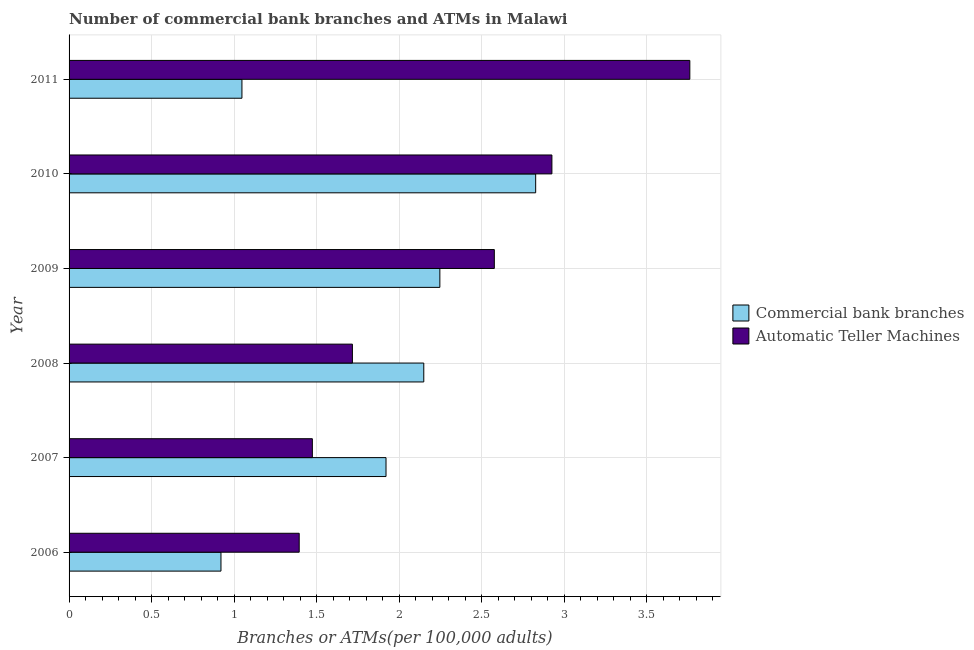Are the number of bars on each tick of the Y-axis equal?
Offer a very short reply. Yes. How many bars are there on the 3rd tick from the bottom?
Make the answer very short. 2. What is the label of the 1st group of bars from the top?
Provide a succinct answer. 2011. In how many cases, is the number of bars for a given year not equal to the number of legend labels?
Offer a terse response. 0. What is the number of atms in 2010?
Make the answer very short. 2.93. Across all years, what is the maximum number of atms?
Give a very brief answer. 3.76. Across all years, what is the minimum number of commercal bank branches?
Provide a short and direct response. 0.92. In which year was the number of atms minimum?
Your answer should be very brief. 2006. What is the total number of commercal bank branches in the graph?
Offer a terse response. 11.11. What is the difference between the number of atms in 2006 and that in 2007?
Your answer should be very brief. -0.08. What is the difference between the number of atms in 2006 and the number of commercal bank branches in 2008?
Your answer should be very brief. -0.75. What is the average number of atms per year?
Provide a short and direct response. 2.31. In the year 2007, what is the difference between the number of commercal bank branches and number of atms?
Keep it short and to the point. 0.45. In how many years, is the number of atms greater than 0.30000000000000004 ?
Provide a succinct answer. 6. What is the ratio of the number of commercal bank branches in 2009 to that in 2011?
Make the answer very short. 2.15. What is the difference between the highest and the second highest number of commercal bank branches?
Your answer should be very brief. 0.58. What is the difference between the highest and the lowest number of commercal bank branches?
Keep it short and to the point. 1.91. In how many years, is the number of commercal bank branches greater than the average number of commercal bank branches taken over all years?
Your answer should be very brief. 4. Is the sum of the number of atms in 2006 and 2007 greater than the maximum number of commercal bank branches across all years?
Provide a short and direct response. Yes. What does the 2nd bar from the top in 2006 represents?
Make the answer very short. Commercial bank branches. What does the 2nd bar from the bottom in 2009 represents?
Make the answer very short. Automatic Teller Machines. How many bars are there?
Give a very brief answer. 12. Are all the bars in the graph horizontal?
Provide a short and direct response. Yes. Does the graph contain any zero values?
Your answer should be very brief. No. Where does the legend appear in the graph?
Provide a short and direct response. Center right. How many legend labels are there?
Offer a terse response. 2. What is the title of the graph?
Your answer should be very brief. Number of commercial bank branches and ATMs in Malawi. Does "Electricity and heat production" appear as one of the legend labels in the graph?
Provide a short and direct response. No. What is the label or title of the X-axis?
Keep it short and to the point. Branches or ATMs(per 100,0 adults). What is the label or title of the Y-axis?
Provide a succinct answer. Year. What is the Branches or ATMs(per 100,000 adults) of Commercial bank branches in 2006?
Ensure brevity in your answer.  0.92. What is the Branches or ATMs(per 100,000 adults) of Automatic Teller Machines in 2006?
Make the answer very short. 1.39. What is the Branches or ATMs(per 100,000 adults) in Commercial bank branches in 2007?
Give a very brief answer. 1.92. What is the Branches or ATMs(per 100,000 adults) in Automatic Teller Machines in 2007?
Keep it short and to the point. 1.47. What is the Branches or ATMs(per 100,000 adults) in Commercial bank branches in 2008?
Provide a succinct answer. 2.15. What is the Branches or ATMs(per 100,000 adults) in Automatic Teller Machines in 2008?
Keep it short and to the point. 1.72. What is the Branches or ATMs(per 100,000 adults) in Commercial bank branches in 2009?
Your answer should be very brief. 2.25. What is the Branches or ATMs(per 100,000 adults) of Automatic Teller Machines in 2009?
Your answer should be compact. 2.58. What is the Branches or ATMs(per 100,000 adults) in Commercial bank branches in 2010?
Your response must be concise. 2.83. What is the Branches or ATMs(per 100,000 adults) of Automatic Teller Machines in 2010?
Make the answer very short. 2.93. What is the Branches or ATMs(per 100,000 adults) of Commercial bank branches in 2011?
Your answer should be compact. 1.05. What is the Branches or ATMs(per 100,000 adults) in Automatic Teller Machines in 2011?
Ensure brevity in your answer.  3.76. Across all years, what is the maximum Branches or ATMs(per 100,000 adults) in Commercial bank branches?
Offer a very short reply. 2.83. Across all years, what is the maximum Branches or ATMs(per 100,000 adults) in Automatic Teller Machines?
Offer a terse response. 3.76. Across all years, what is the minimum Branches or ATMs(per 100,000 adults) of Commercial bank branches?
Give a very brief answer. 0.92. Across all years, what is the minimum Branches or ATMs(per 100,000 adults) in Automatic Teller Machines?
Give a very brief answer. 1.39. What is the total Branches or ATMs(per 100,000 adults) of Commercial bank branches in the graph?
Your response must be concise. 11.11. What is the total Branches or ATMs(per 100,000 adults) of Automatic Teller Machines in the graph?
Your answer should be very brief. 13.85. What is the difference between the Branches or ATMs(per 100,000 adults) of Commercial bank branches in 2006 and that in 2007?
Provide a short and direct response. -1. What is the difference between the Branches or ATMs(per 100,000 adults) of Automatic Teller Machines in 2006 and that in 2007?
Keep it short and to the point. -0.08. What is the difference between the Branches or ATMs(per 100,000 adults) of Commercial bank branches in 2006 and that in 2008?
Provide a short and direct response. -1.23. What is the difference between the Branches or ATMs(per 100,000 adults) in Automatic Teller Machines in 2006 and that in 2008?
Give a very brief answer. -0.32. What is the difference between the Branches or ATMs(per 100,000 adults) of Commercial bank branches in 2006 and that in 2009?
Keep it short and to the point. -1.33. What is the difference between the Branches or ATMs(per 100,000 adults) of Automatic Teller Machines in 2006 and that in 2009?
Provide a short and direct response. -1.18. What is the difference between the Branches or ATMs(per 100,000 adults) of Commercial bank branches in 2006 and that in 2010?
Your answer should be compact. -1.91. What is the difference between the Branches or ATMs(per 100,000 adults) in Automatic Teller Machines in 2006 and that in 2010?
Provide a short and direct response. -1.53. What is the difference between the Branches or ATMs(per 100,000 adults) in Commercial bank branches in 2006 and that in 2011?
Ensure brevity in your answer.  -0.13. What is the difference between the Branches or ATMs(per 100,000 adults) in Automatic Teller Machines in 2006 and that in 2011?
Your answer should be compact. -2.37. What is the difference between the Branches or ATMs(per 100,000 adults) of Commercial bank branches in 2007 and that in 2008?
Your response must be concise. -0.23. What is the difference between the Branches or ATMs(per 100,000 adults) of Automatic Teller Machines in 2007 and that in 2008?
Provide a succinct answer. -0.24. What is the difference between the Branches or ATMs(per 100,000 adults) of Commercial bank branches in 2007 and that in 2009?
Provide a short and direct response. -0.33. What is the difference between the Branches or ATMs(per 100,000 adults) in Automatic Teller Machines in 2007 and that in 2009?
Ensure brevity in your answer.  -1.1. What is the difference between the Branches or ATMs(per 100,000 adults) in Commercial bank branches in 2007 and that in 2010?
Make the answer very short. -0.91. What is the difference between the Branches or ATMs(per 100,000 adults) of Automatic Teller Machines in 2007 and that in 2010?
Ensure brevity in your answer.  -1.45. What is the difference between the Branches or ATMs(per 100,000 adults) of Commercial bank branches in 2007 and that in 2011?
Your answer should be compact. 0.87. What is the difference between the Branches or ATMs(per 100,000 adults) of Automatic Teller Machines in 2007 and that in 2011?
Your answer should be very brief. -2.29. What is the difference between the Branches or ATMs(per 100,000 adults) of Commercial bank branches in 2008 and that in 2009?
Your answer should be compact. -0.1. What is the difference between the Branches or ATMs(per 100,000 adults) in Automatic Teller Machines in 2008 and that in 2009?
Offer a very short reply. -0.86. What is the difference between the Branches or ATMs(per 100,000 adults) of Commercial bank branches in 2008 and that in 2010?
Keep it short and to the point. -0.68. What is the difference between the Branches or ATMs(per 100,000 adults) in Automatic Teller Machines in 2008 and that in 2010?
Ensure brevity in your answer.  -1.21. What is the difference between the Branches or ATMs(per 100,000 adults) in Commercial bank branches in 2008 and that in 2011?
Give a very brief answer. 1.1. What is the difference between the Branches or ATMs(per 100,000 adults) in Automatic Teller Machines in 2008 and that in 2011?
Your answer should be compact. -2.04. What is the difference between the Branches or ATMs(per 100,000 adults) of Commercial bank branches in 2009 and that in 2010?
Offer a terse response. -0.58. What is the difference between the Branches or ATMs(per 100,000 adults) of Automatic Teller Machines in 2009 and that in 2010?
Your answer should be compact. -0.35. What is the difference between the Branches or ATMs(per 100,000 adults) in Commercial bank branches in 2009 and that in 2011?
Give a very brief answer. 1.2. What is the difference between the Branches or ATMs(per 100,000 adults) in Automatic Teller Machines in 2009 and that in 2011?
Provide a short and direct response. -1.18. What is the difference between the Branches or ATMs(per 100,000 adults) of Commercial bank branches in 2010 and that in 2011?
Offer a very short reply. 1.78. What is the difference between the Branches or ATMs(per 100,000 adults) in Automatic Teller Machines in 2010 and that in 2011?
Make the answer very short. -0.84. What is the difference between the Branches or ATMs(per 100,000 adults) in Commercial bank branches in 2006 and the Branches or ATMs(per 100,000 adults) in Automatic Teller Machines in 2007?
Your response must be concise. -0.55. What is the difference between the Branches or ATMs(per 100,000 adults) in Commercial bank branches in 2006 and the Branches or ATMs(per 100,000 adults) in Automatic Teller Machines in 2008?
Your answer should be very brief. -0.8. What is the difference between the Branches or ATMs(per 100,000 adults) in Commercial bank branches in 2006 and the Branches or ATMs(per 100,000 adults) in Automatic Teller Machines in 2009?
Your answer should be very brief. -1.66. What is the difference between the Branches or ATMs(per 100,000 adults) of Commercial bank branches in 2006 and the Branches or ATMs(per 100,000 adults) of Automatic Teller Machines in 2010?
Offer a terse response. -2.01. What is the difference between the Branches or ATMs(per 100,000 adults) of Commercial bank branches in 2006 and the Branches or ATMs(per 100,000 adults) of Automatic Teller Machines in 2011?
Give a very brief answer. -2.84. What is the difference between the Branches or ATMs(per 100,000 adults) of Commercial bank branches in 2007 and the Branches or ATMs(per 100,000 adults) of Automatic Teller Machines in 2008?
Provide a short and direct response. 0.2. What is the difference between the Branches or ATMs(per 100,000 adults) of Commercial bank branches in 2007 and the Branches or ATMs(per 100,000 adults) of Automatic Teller Machines in 2009?
Provide a short and direct response. -0.66. What is the difference between the Branches or ATMs(per 100,000 adults) of Commercial bank branches in 2007 and the Branches or ATMs(per 100,000 adults) of Automatic Teller Machines in 2010?
Your answer should be very brief. -1.01. What is the difference between the Branches or ATMs(per 100,000 adults) of Commercial bank branches in 2007 and the Branches or ATMs(per 100,000 adults) of Automatic Teller Machines in 2011?
Offer a terse response. -1.84. What is the difference between the Branches or ATMs(per 100,000 adults) of Commercial bank branches in 2008 and the Branches or ATMs(per 100,000 adults) of Automatic Teller Machines in 2009?
Make the answer very short. -0.43. What is the difference between the Branches or ATMs(per 100,000 adults) of Commercial bank branches in 2008 and the Branches or ATMs(per 100,000 adults) of Automatic Teller Machines in 2010?
Offer a very short reply. -0.78. What is the difference between the Branches or ATMs(per 100,000 adults) in Commercial bank branches in 2008 and the Branches or ATMs(per 100,000 adults) in Automatic Teller Machines in 2011?
Your answer should be compact. -1.61. What is the difference between the Branches or ATMs(per 100,000 adults) of Commercial bank branches in 2009 and the Branches or ATMs(per 100,000 adults) of Automatic Teller Machines in 2010?
Your response must be concise. -0.68. What is the difference between the Branches or ATMs(per 100,000 adults) in Commercial bank branches in 2009 and the Branches or ATMs(per 100,000 adults) in Automatic Teller Machines in 2011?
Your answer should be compact. -1.51. What is the difference between the Branches or ATMs(per 100,000 adults) of Commercial bank branches in 2010 and the Branches or ATMs(per 100,000 adults) of Automatic Teller Machines in 2011?
Provide a succinct answer. -0.93. What is the average Branches or ATMs(per 100,000 adults) in Commercial bank branches per year?
Provide a short and direct response. 1.85. What is the average Branches or ATMs(per 100,000 adults) in Automatic Teller Machines per year?
Offer a terse response. 2.31. In the year 2006, what is the difference between the Branches or ATMs(per 100,000 adults) of Commercial bank branches and Branches or ATMs(per 100,000 adults) of Automatic Teller Machines?
Provide a succinct answer. -0.47. In the year 2007, what is the difference between the Branches or ATMs(per 100,000 adults) of Commercial bank branches and Branches or ATMs(per 100,000 adults) of Automatic Teller Machines?
Provide a succinct answer. 0.45. In the year 2008, what is the difference between the Branches or ATMs(per 100,000 adults) in Commercial bank branches and Branches or ATMs(per 100,000 adults) in Automatic Teller Machines?
Provide a short and direct response. 0.43. In the year 2009, what is the difference between the Branches or ATMs(per 100,000 adults) of Commercial bank branches and Branches or ATMs(per 100,000 adults) of Automatic Teller Machines?
Offer a very short reply. -0.33. In the year 2010, what is the difference between the Branches or ATMs(per 100,000 adults) in Commercial bank branches and Branches or ATMs(per 100,000 adults) in Automatic Teller Machines?
Ensure brevity in your answer.  -0.1. In the year 2011, what is the difference between the Branches or ATMs(per 100,000 adults) of Commercial bank branches and Branches or ATMs(per 100,000 adults) of Automatic Teller Machines?
Provide a short and direct response. -2.71. What is the ratio of the Branches or ATMs(per 100,000 adults) of Commercial bank branches in 2006 to that in 2007?
Offer a terse response. 0.48. What is the ratio of the Branches or ATMs(per 100,000 adults) in Automatic Teller Machines in 2006 to that in 2007?
Your answer should be very brief. 0.95. What is the ratio of the Branches or ATMs(per 100,000 adults) of Commercial bank branches in 2006 to that in 2008?
Give a very brief answer. 0.43. What is the ratio of the Branches or ATMs(per 100,000 adults) in Automatic Teller Machines in 2006 to that in 2008?
Give a very brief answer. 0.81. What is the ratio of the Branches or ATMs(per 100,000 adults) of Commercial bank branches in 2006 to that in 2009?
Your answer should be very brief. 0.41. What is the ratio of the Branches or ATMs(per 100,000 adults) of Automatic Teller Machines in 2006 to that in 2009?
Offer a very short reply. 0.54. What is the ratio of the Branches or ATMs(per 100,000 adults) in Commercial bank branches in 2006 to that in 2010?
Keep it short and to the point. 0.33. What is the ratio of the Branches or ATMs(per 100,000 adults) in Automatic Teller Machines in 2006 to that in 2010?
Make the answer very short. 0.48. What is the ratio of the Branches or ATMs(per 100,000 adults) of Commercial bank branches in 2006 to that in 2011?
Your answer should be compact. 0.88. What is the ratio of the Branches or ATMs(per 100,000 adults) of Automatic Teller Machines in 2006 to that in 2011?
Keep it short and to the point. 0.37. What is the ratio of the Branches or ATMs(per 100,000 adults) of Commercial bank branches in 2007 to that in 2008?
Make the answer very short. 0.89. What is the ratio of the Branches or ATMs(per 100,000 adults) of Automatic Teller Machines in 2007 to that in 2008?
Offer a very short reply. 0.86. What is the ratio of the Branches or ATMs(per 100,000 adults) in Commercial bank branches in 2007 to that in 2009?
Ensure brevity in your answer.  0.85. What is the ratio of the Branches or ATMs(per 100,000 adults) of Automatic Teller Machines in 2007 to that in 2009?
Your answer should be very brief. 0.57. What is the ratio of the Branches or ATMs(per 100,000 adults) of Commercial bank branches in 2007 to that in 2010?
Offer a very short reply. 0.68. What is the ratio of the Branches or ATMs(per 100,000 adults) in Automatic Teller Machines in 2007 to that in 2010?
Offer a very short reply. 0.5. What is the ratio of the Branches or ATMs(per 100,000 adults) in Commercial bank branches in 2007 to that in 2011?
Offer a very short reply. 1.83. What is the ratio of the Branches or ATMs(per 100,000 adults) of Automatic Teller Machines in 2007 to that in 2011?
Give a very brief answer. 0.39. What is the ratio of the Branches or ATMs(per 100,000 adults) of Commercial bank branches in 2008 to that in 2009?
Keep it short and to the point. 0.96. What is the ratio of the Branches or ATMs(per 100,000 adults) of Automatic Teller Machines in 2008 to that in 2009?
Your answer should be compact. 0.67. What is the ratio of the Branches or ATMs(per 100,000 adults) in Commercial bank branches in 2008 to that in 2010?
Offer a very short reply. 0.76. What is the ratio of the Branches or ATMs(per 100,000 adults) in Automatic Teller Machines in 2008 to that in 2010?
Make the answer very short. 0.59. What is the ratio of the Branches or ATMs(per 100,000 adults) in Commercial bank branches in 2008 to that in 2011?
Offer a very short reply. 2.05. What is the ratio of the Branches or ATMs(per 100,000 adults) in Automatic Teller Machines in 2008 to that in 2011?
Provide a short and direct response. 0.46. What is the ratio of the Branches or ATMs(per 100,000 adults) in Commercial bank branches in 2009 to that in 2010?
Keep it short and to the point. 0.79. What is the ratio of the Branches or ATMs(per 100,000 adults) of Automatic Teller Machines in 2009 to that in 2010?
Offer a very short reply. 0.88. What is the ratio of the Branches or ATMs(per 100,000 adults) in Commercial bank branches in 2009 to that in 2011?
Offer a terse response. 2.14. What is the ratio of the Branches or ATMs(per 100,000 adults) in Automatic Teller Machines in 2009 to that in 2011?
Your answer should be very brief. 0.69. What is the ratio of the Branches or ATMs(per 100,000 adults) of Commercial bank branches in 2010 to that in 2011?
Offer a terse response. 2.7. What is the difference between the highest and the second highest Branches or ATMs(per 100,000 adults) of Commercial bank branches?
Your answer should be compact. 0.58. What is the difference between the highest and the second highest Branches or ATMs(per 100,000 adults) of Automatic Teller Machines?
Your answer should be very brief. 0.84. What is the difference between the highest and the lowest Branches or ATMs(per 100,000 adults) of Commercial bank branches?
Provide a succinct answer. 1.91. What is the difference between the highest and the lowest Branches or ATMs(per 100,000 adults) of Automatic Teller Machines?
Keep it short and to the point. 2.37. 